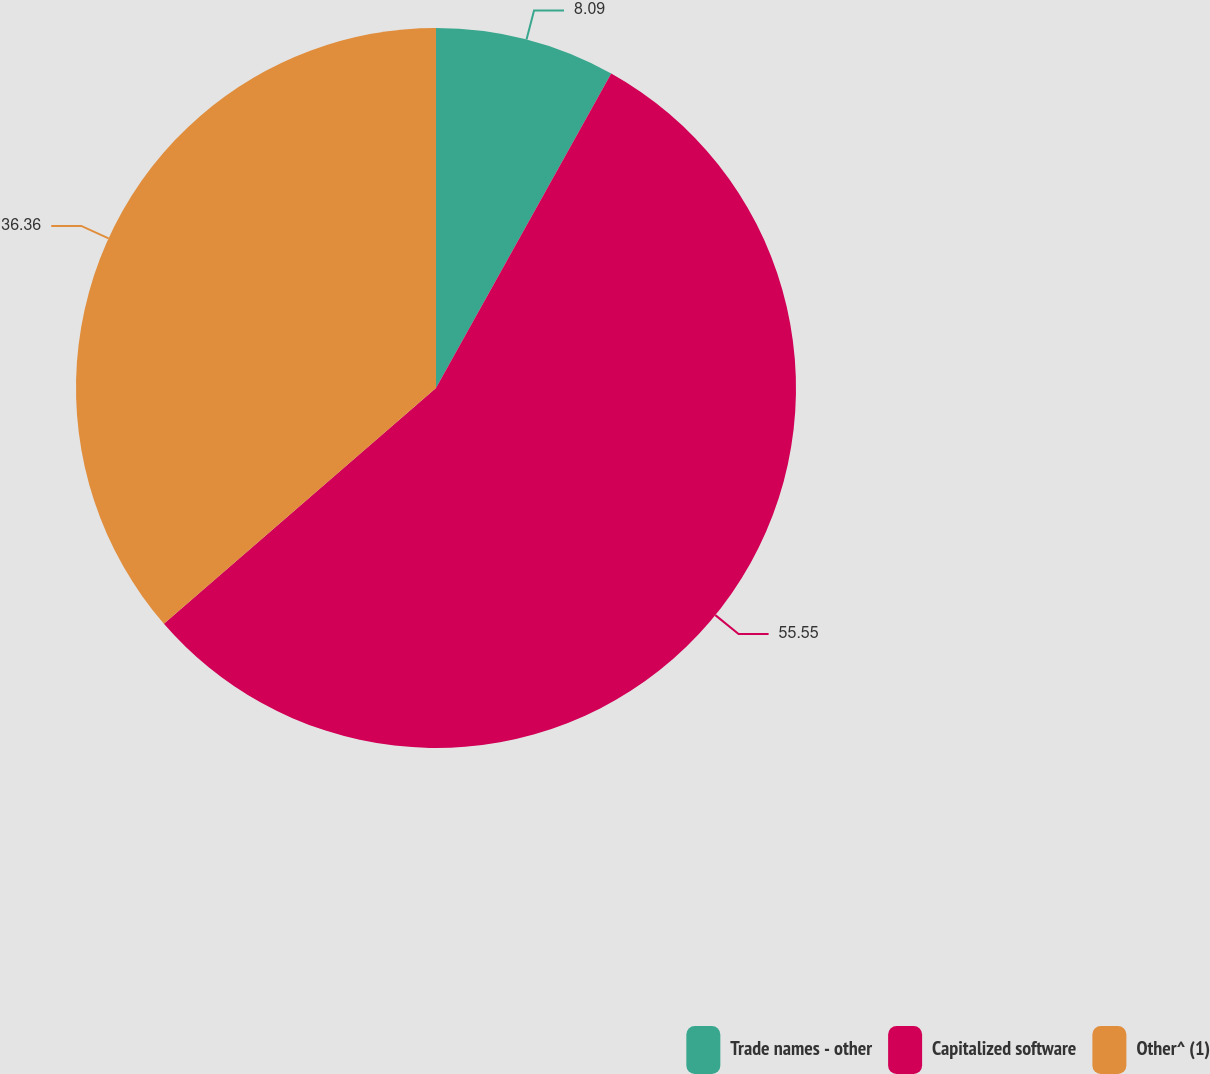Convert chart. <chart><loc_0><loc_0><loc_500><loc_500><pie_chart><fcel>Trade names - other<fcel>Capitalized software<fcel>Other^ (1)<nl><fcel>8.09%<fcel>55.55%<fcel>36.36%<nl></chart> 